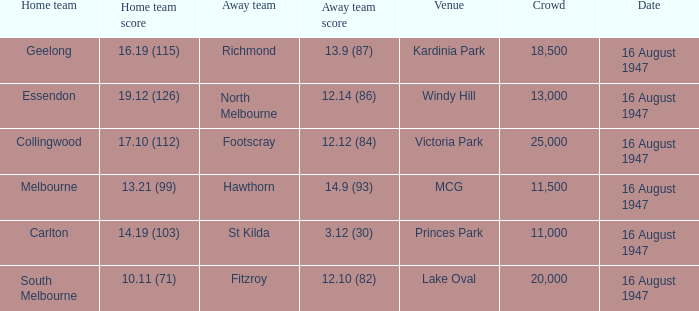What venue had footscray play at it? Victoria Park. Can you give me this table as a dict? {'header': ['Home team', 'Home team score', 'Away team', 'Away team score', 'Venue', 'Crowd', 'Date'], 'rows': [['Geelong', '16.19 (115)', 'Richmond', '13.9 (87)', 'Kardinia Park', '18,500', '16 August 1947'], ['Essendon', '19.12 (126)', 'North Melbourne', '12.14 (86)', 'Windy Hill', '13,000', '16 August 1947'], ['Collingwood', '17.10 (112)', 'Footscray', '12.12 (84)', 'Victoria Park', '25,000', '16 August 1947'], ['Melbourne', '13.21 (99)', 'Hawthorn', '14.9 (93)', 'MCG', '11,500', '16 August 1947'], ['Carlton', '14.19 (103)', 'St Kilda', '3.12 (30)', 'Princes Park', '11,000', '16 August 1947'], ['South Melbourne', '10.11 (71)', 'Fitzroy', '12.10 (82)', 'Lake Oval', '20,000', '16 August 1947']]} 